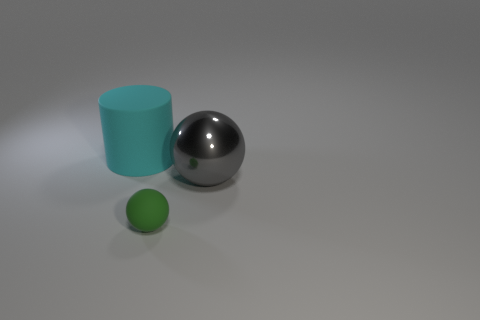What size is the green thing that is the same shape as the gray object?
Your answer should be compact. Small. Do the matte object left of the tiny green sphere and the rubber thing in front of the cyan rubber object have the same shape?
Provide a succinct answer. No. There is a matte cylinder; is it the same size as the thing that is in front of the gray ball?
Your answer should be very brief. No. What number of other things are the same material as the big cyan cylinder?
Offer a terse response. 1. Is there any other thing that has the same shape as the green thing?
Give a very brief answer. Yes. There is a ball behind the matte thing that is in front of the big object that is to the right of the green sphere; what color is it?
Your response must be concise. Gray. What shape is the object that is in front of the big cylinder and left of the large shiny object?
Your answer should be very brief. Sphere. Is there any other thing that is the same size as the green thing?
Your response must be concise. No. What color is the matte object that is behind the thing on the right side of the small object?
Provide a succinct answer. Cyan. What is the shape of the rubber object that is to the left of the matte object that is to the right of the big matte cylinder that is behind the large gray shiny thing?
Make the answer very short. Cylinder. 